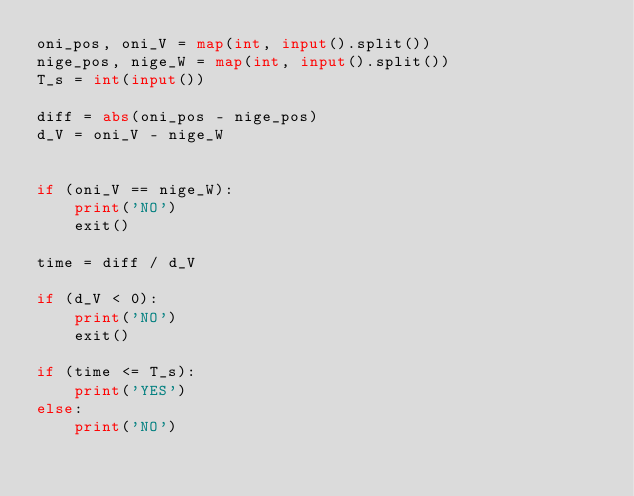Convert code to text. <code><loc_0><loc_0><loc_500><loc_500><_Python_>oni_pos, oni_V = map(int, input().split())
nige_pos, nige_W = map(int, input().split())
T_s = int(input())

diff = abs(oni_pos - nige_pos)
d_V = oni_V - nige_W


if (oni_V == nige_W):
    print('NO')
    exit()

time = diff / d_V

if (d_V < 0):
    print('NO')
    exit()
    
if (time <= T_s):
    print('YES')
else:
    print('NO')

</code> 